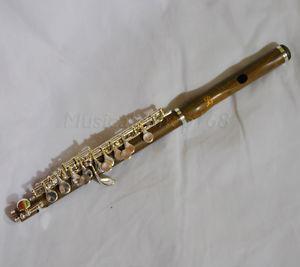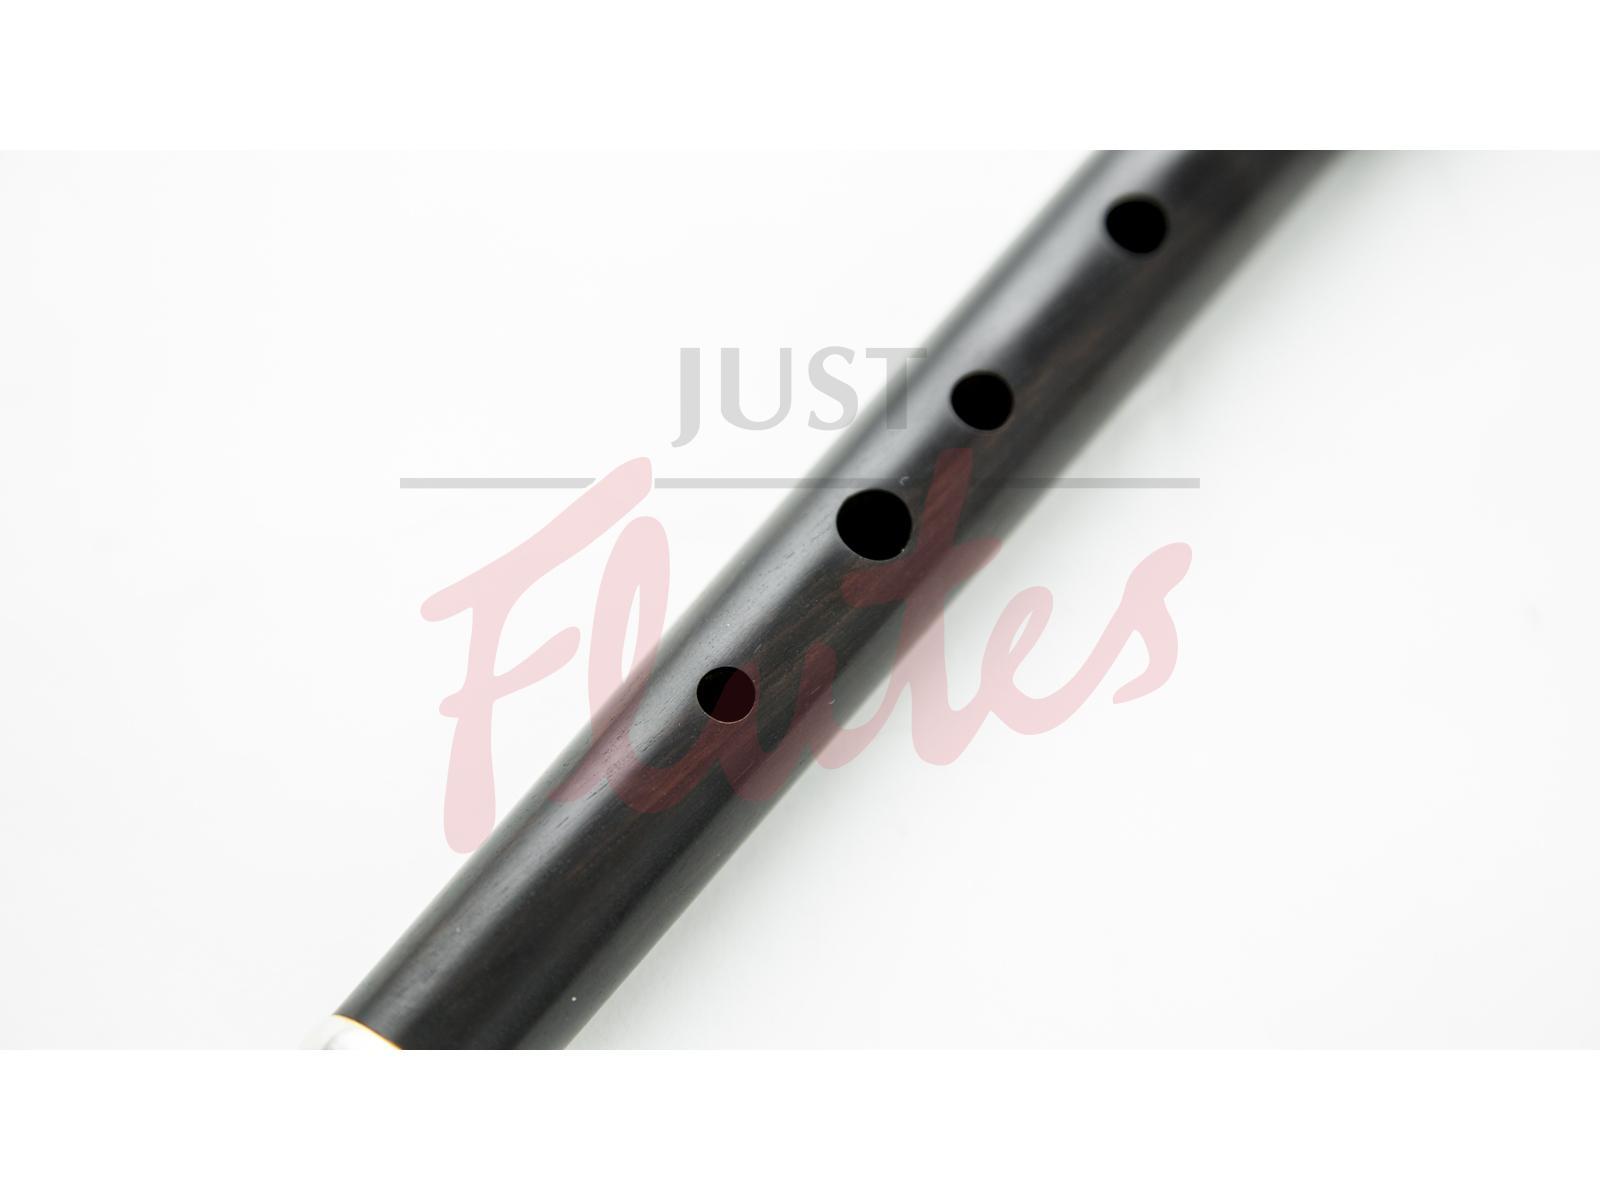The first image is the image on the left, the second image is the image on the right. Given the left and right images, does the statement "The left image contains only a diagonally displayed flute with metal buttons, and the right image includes only a diagonally displayed flute without metal buttons." hold true? Answer yes or no. Yes. The first image is the image on the left, the second image is the image on the right. For the images shown, is this caption "One of the images shows an instrument with buttons that are pressed to change notes while the other just has finger holes that get covered to changed notes." true? Answer yes or no. Yes. 